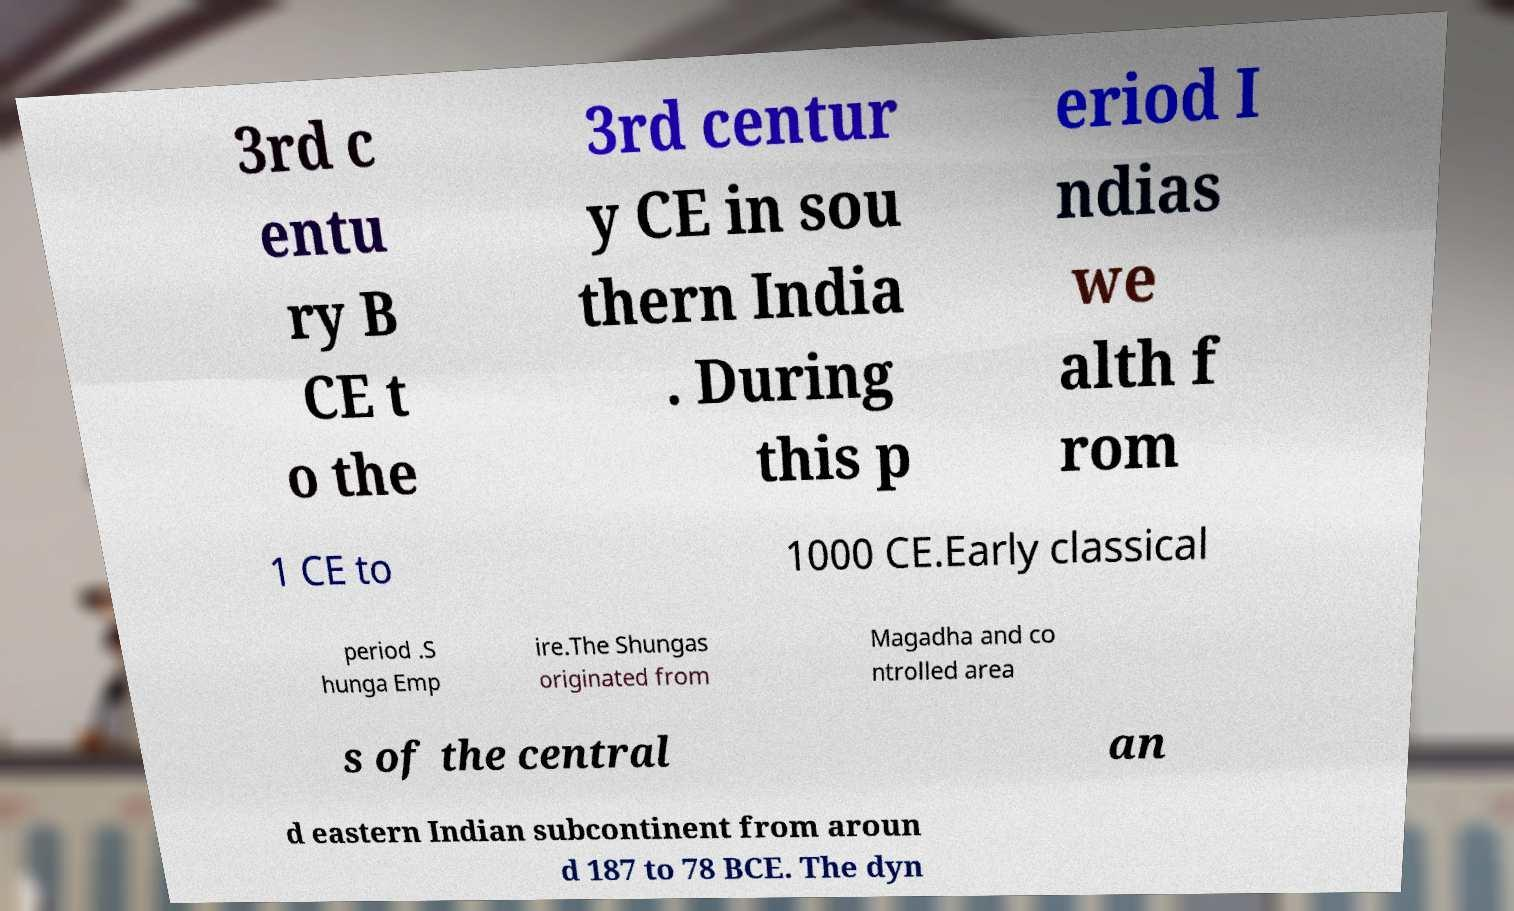I need the written content from this picture converted into text. Can you do that? 3rd c entu ry B CE t o the 3rd centur y CE in sou thern India . During this p eriod I ndias we alth f rom 1 CE to 1000 CE.Early classical period .S hunga Emp ire.The Shungas originated from Magadha and co ntrolled area s of the central an d eastern Indian subcontinent from aroun d 187 to 78 BCE. The dyn 